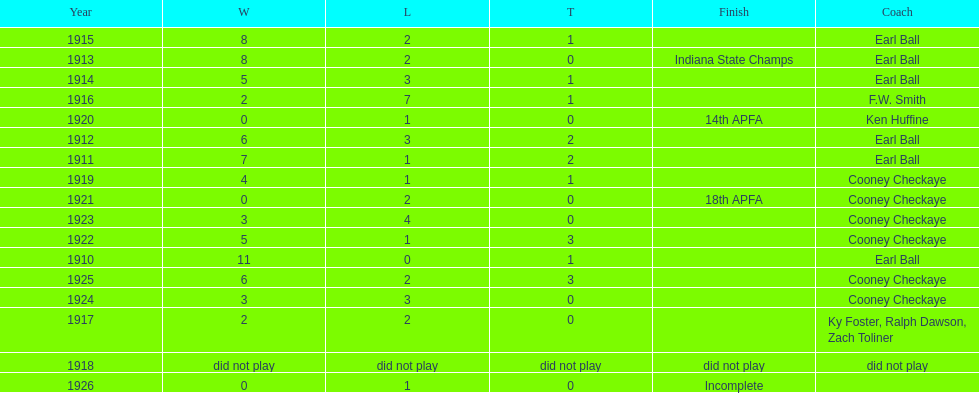How many years did cooney checkaye coach the muncie flyers? 6. 